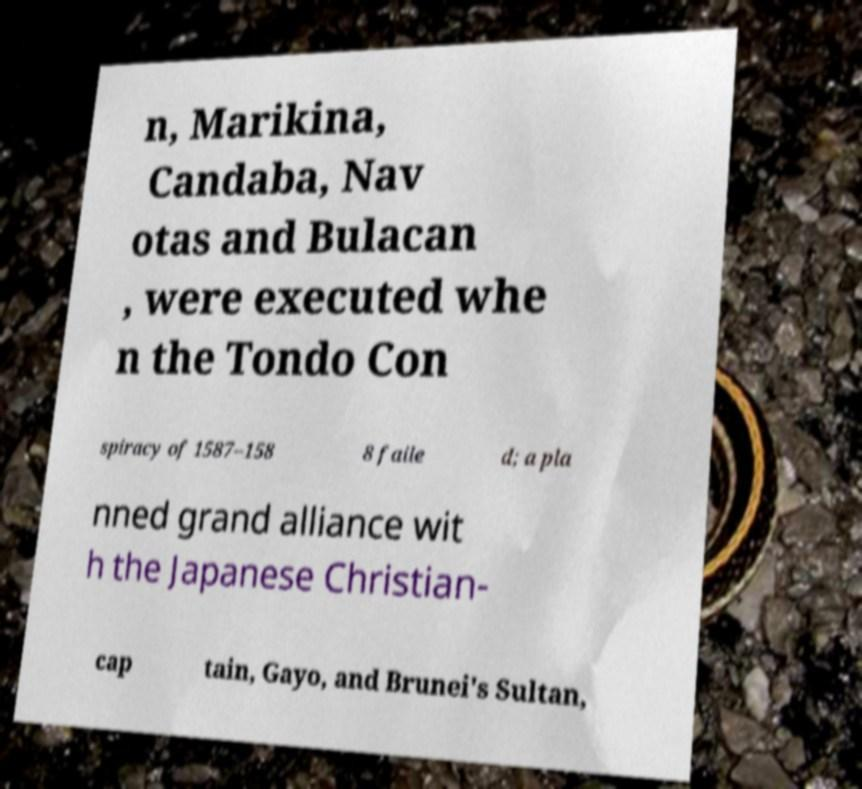Please identify and transcribe the text found in this image. n, Marikina, Candaba, Nav otas and Bulacan , were executed whe n the Tondo Con spiracy of 1587–158 8 faile d; a pla nned grand alliance wit h the Japanese Christian- cap tain, Gayo, and Brunei's Sultan, 